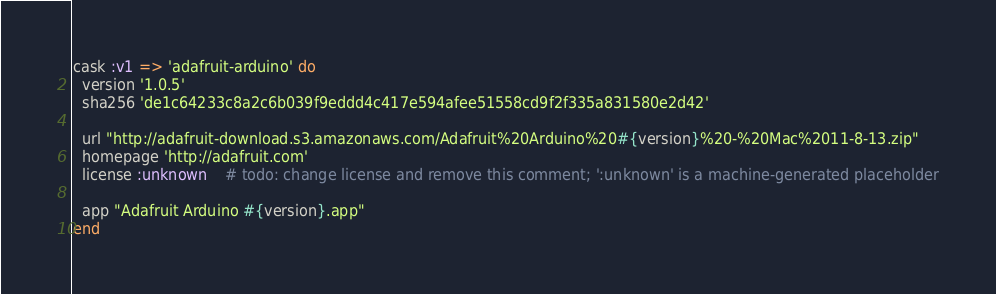Convert code to text. <code><loc_0><loc_0><loc_500><loc_500><_Ruby_>cask :v1 => 'adafruit-arduino' do
  version '1.0.5'
  sha256 'de1c64233c8a2c6b039f9eddd4c417e594afee51558cd9f2f335a831580e2d42'

  url "http://adafruit-download.s3.amazonaws.com/Adafruit%20Arduino%20#{version}%20-%20Mac%2011-8-13.zip"
  homepage 'http://adafruit.com'
  license :unknown    # todo: change license and remove this comment; ':unknown' is a machine-generated placeholder

  app "Adafruit Arduino #{version}.app"
end
</code> 